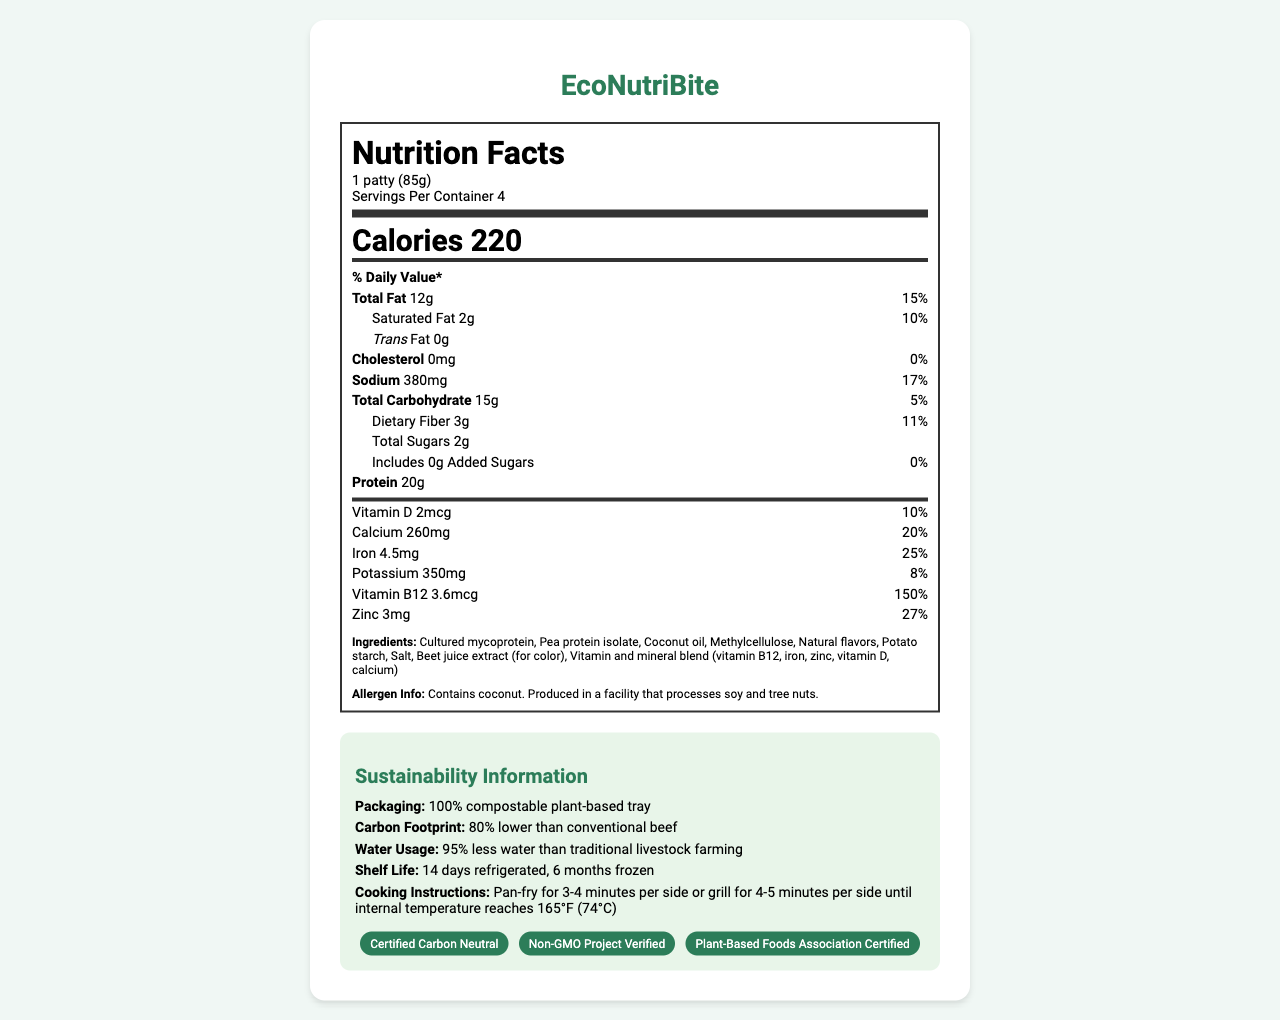what is the serving size of EcoNutriBite? The serving size is mentioned under the product name and is specified as "1 patty (85g)."
Answer: 1 patty (85g) how many calories are in one serving of EcoNutriBite? "Calories 220" is clearly stated in the nutrition facts section.
Answer: 220 how much protein does one serving contain? The amount of protein is listed in the nutrients section with "Protein 20g."
Answer: 20g what percentage of daily value does the vitamin B12 content cover per serving? In the micronutrient section, it shows "Vitamin B12 3.6mcg," followed by "150%."
Answer: 150% what are the main ingredients of EcoNutriBite? The ingredients are listed at the bottom of the nutrition label, under the heading "Ingredients."
Answer: Cultured mycoprotein, Pea protein isolate, Coconut oil, Methylcellulose, Natural flavors, Potato starch, Salt, Beet juice extract (for color), Vitamin and mineral blend (vitamin B12, iron, zinc, vitamin D, calcium) what is the carbon footprint reduction compared to conventional beef? Under the Sustainability Information section, it states "Carbon Footprint: 80% lower than conventional beef."
Answer: 80% which of the following is not an ingredient in EcoNutriBite? A. Cultured mycoprotein B. Rice Flour C. Beet juice extract D. Pea protein isolate The ingredients list does not include Rice Flour but does include the others.
Answer: B how many servings are there per container? A. 2 B. 3 C. 4 D. 5 The serving info states "Servings Per Container 4."
Answer: C does EcoNutriBite contain any trans fat? The nutrition label shows "Trans Fat 0g," indicating the product does not contain any trans fat.
Answer: No does the product have sustainability certifications? The eco-info section lists certifications such as "Certified Carbon Neutral," "Non-GMO Project Verified," and "Plant-Based Foods Association Certified."
Answer: Yes provide a summary of the EcoNutriBite Nutrition Facts label. This summary encapsulates the primary nutritional information, ingredients, target audience, and sustainability features as described in the document.
Answer: EcoNutriBite is a novel, lab-grown food product aimed at sustainable consumption. It offers 220 calories per serving, with key nutrients including 20g of protein, 12g of total fat, 15g of carbohydrates, and a significant amount of vitamins and minerals. Ingredients feature cultured mycoprotein and pea protein isolate. It is designed for environmentally conscious consumers, featuring 100% compostable packaging, an 80% lower carbon footprint than conventional beef, and significantly reduced water usage. Allergen information indicates it contains coconut and may be processed in a facility with soy and tree nuts. The product has multiple sustainability certifications and is geared towards flexitarians and vegans. how long can EcoNutriBite be stored in the refrigerator? According to the Sustainability Information, the shelf life is "14 days refrigerated."
Answer: 14 days what certifications does EcoNutriBite have? The certifications are listed at the bottom of the eco-info section in the Sustainability Information area.
Answer: Certified Carbon Neutral, Non-GMO Project Verified, Plant-Based Foods Association Certified how much iron does one serving of EcoNutriBite contain? A. 4.5mg B. 3.6mcg C. 2mcg D. 350mg The nutrient section lists "Iron 4.5mg" with a daily value percentage of 25%.
Answer: A is there enough information to determine the price of EcoNutriBite? The document does not provide any information on the price of the product; hence, it is not possible to determine the price.
Answer: No 